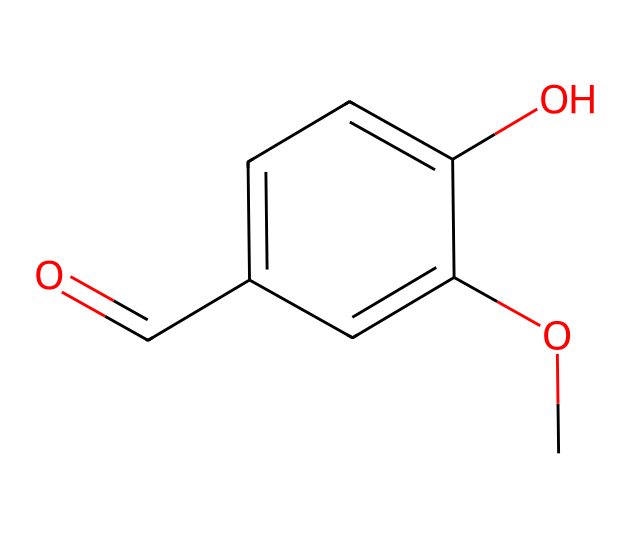What is the main functional group present in this chemical? The chemical structure has a methoxy group (-OCH3) and a hydroxyl group (-OH), which are both functional groups. However, the most prominent functional group here, considering the general reactivity and the presence of a carbonyl, is the aldehyde group (C=O).
Answer: aldehyde How many carbon atoms are in this chemical? By analyzing the SMILES representation, we can identify that there are six carbon atoms represented in the aromatic ring and one from the aldehyde group. Counting them gives a total of seven carbon atoms.
Answer: seven What type of bond connects the carbonyl group to the aromatic ring? The carbonyl group (C=O) is primarily connected by a single covalent bond to the aromatic ring, allowing it to be part of the overall structure, which influences the properties and reactivity of the compound.
Answer: single What is the molecular formula of this chemical? From the SMILES representation, we can deduce the molecular formula by counting the atoms of each element: 8 carbon atoms, 8 hydrogen atoms, and 3 oxygen atoms, leading to the molecular formula C8H8O3.
Answer: C8H8O3 What properties might the hydroxyl group contribute to this chemical? The presence of the hydroxyl group (-OH) indicates the chemical will have polar properties, allowing it to engage in hydrogen bonding, which could enhance its solubility in water and influence its boiling point.
Answer: polar What is the functional role of the methoxy group in this chemical? The methoxy group (-OCH3) in this structure can act as an electron-donating group, which stabilizes the overall molecule and alters its reactivity, particularly in reactions involving electrophilic aromatic substitution.
Answer: electron-donating 